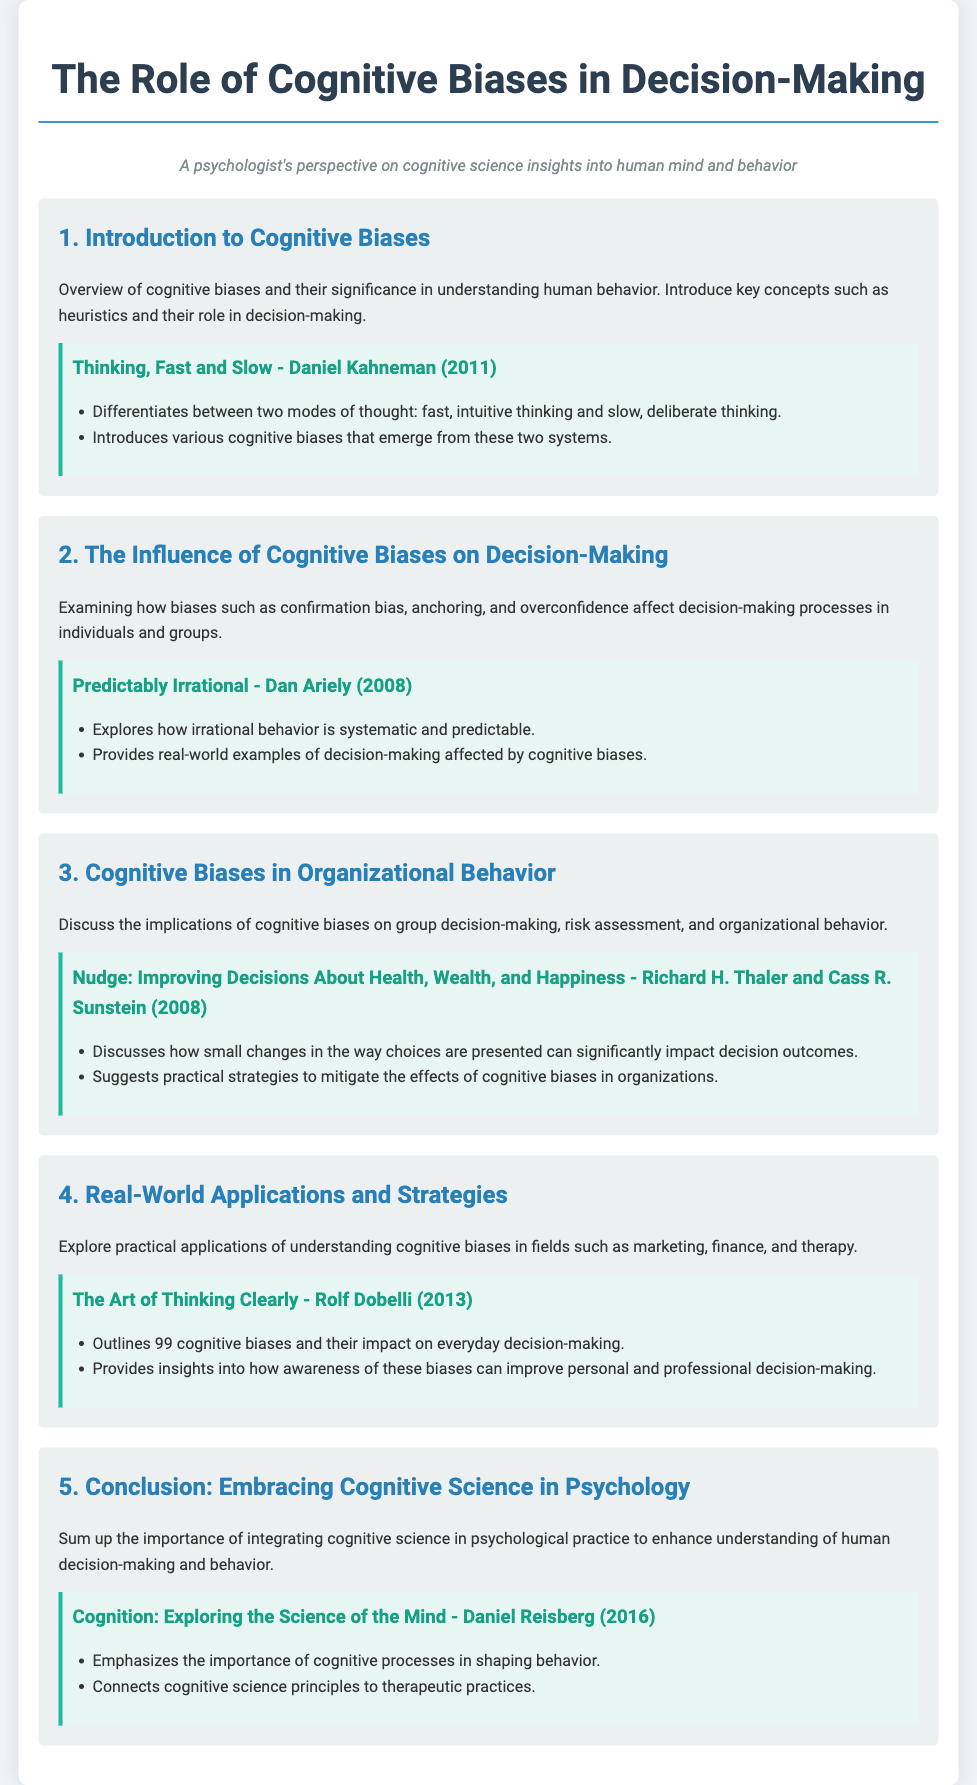What is the title of the document? The title of the document is indicated at the top of the agenda, which states the topic of discussion.
Answer: The Role of Cognitive Biases in Decision-Making Who is the author of "Thinking, Fast and Slow"? The authorship of the text referenced in the first agenda item provides the name of the author.
Answer: Daniel Kahneman What does cognitive bias influence according to the second agenda item? The second agenda item discusses specific biases and their effects on a particular process, which is detailed in its description.
Answer: Decision-making processes Which cognitive biases are mentioned in the second agenda item? The text explicitly names three cognitive biases that are examined in the context of decision-making.
Answer: Confirmation bias, anchoring, and overconfidence What year was "Nudge: Improving Decisions About Health, Wealth, and Happiness" published? The publication year of the source referenced in the third agenda item provides necessary data for the question.
Answer: 2008 What is the focus of the fourth agenda item? The fourth agenda item outlines the practical applications of understanding biases in various fields, as stated in its description.
Answer: Practical applications How many cognitive biases does "The Art of Thinking Clearly" outline? The document indicates a specific number of cognitive biases discussed in the source linked to the fourth agenda item.
Answer: 99 Which cognitive science concept is emphasized in the conclusion? The last agenda item succinctly mentions a key aspect that is vital for enhancing psychological practice.
Answer: Integration of cognitive science What is the purpose of the agenda document? The agenda provides a structured outline of discussion topics related to cognitive biases and decision-making, identifiable from the introductory descriptions.
Answer: To explore cognitive biases in decision-making 